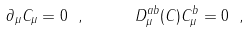<formula> <loc_0><loc_0><loc_500><loc_500>\partial _ { \mu } C _ { \mu } = 0 \ , \quad \ \ D _ { \mu } ^ { a b } ( C ) C _ { \mu } ^ { b } = 0 \ ,</formula> 